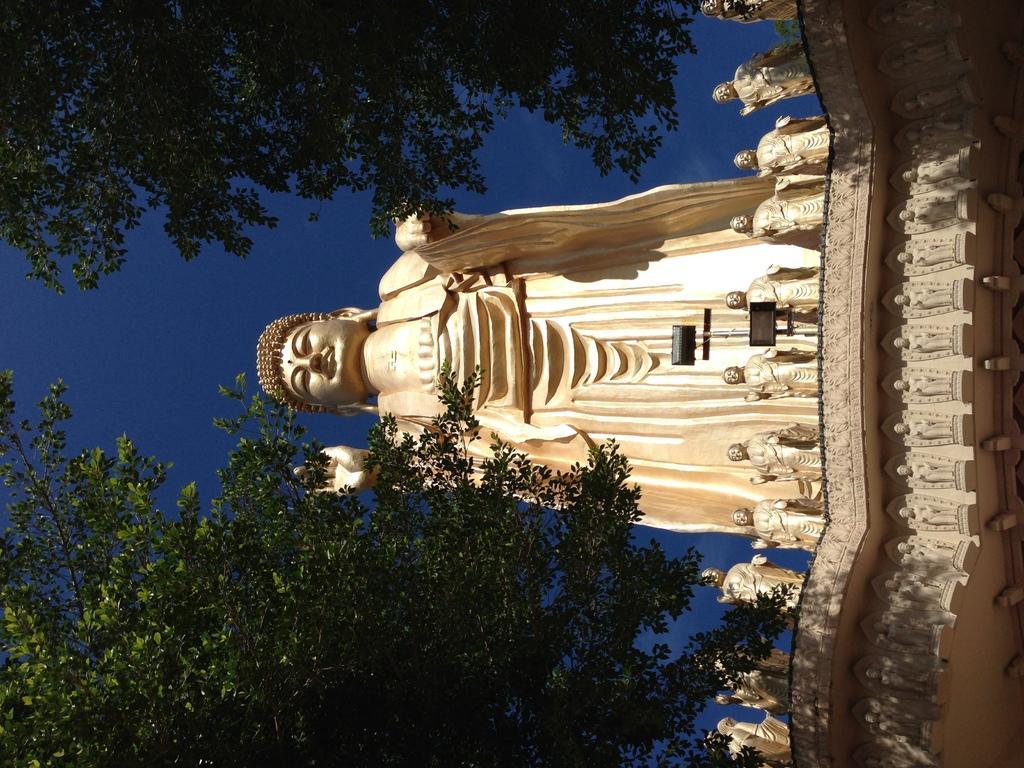Could you give a brief overview of what you see in this image? In this picture we can see few statues, lights and trees. 